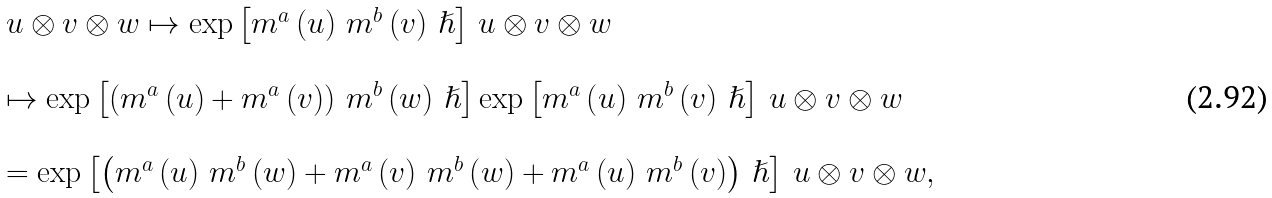Convert formula to latex. <formula><loc_0><loc_0><loc_500><loc_500>\begin{array} { l } u \otimes v \otimes w \mapsto \exp \left [ m ^ { a } \left ( u \right ) \, m ^ { b } \left ( v \right ) \, \hslash \right ] \, u \otimes v \otimes w \\ \\ \mapsto \exp \left [ \left ( m ^ { a } \left ( u \right ) + m ^ { a } \left ( v \right ) \right ) \, m ^ { b } \left ( w \right ) \, \hslash \right ] \exp \left [ m ^ { a } \left ( u \right ) \, m ^ { b } \left ( v \right ) \, \hslash \right ] \, u \otimes v \otimes w \\ \\ = \exp \left [ \left ( m ^ { a } \left ( u \right ) \, m ^ { b } \left ( w \right ) + m ^ { a } \left ( v \right ) \, m ^ { b } \left ( w \right ) + m ^ { a } \left ( u \right ) \, m ^ { b } \left ( v \right ) \right ) \, \hslash \right ] \, u \otimes v \otimes w , \end{array}</formula> 